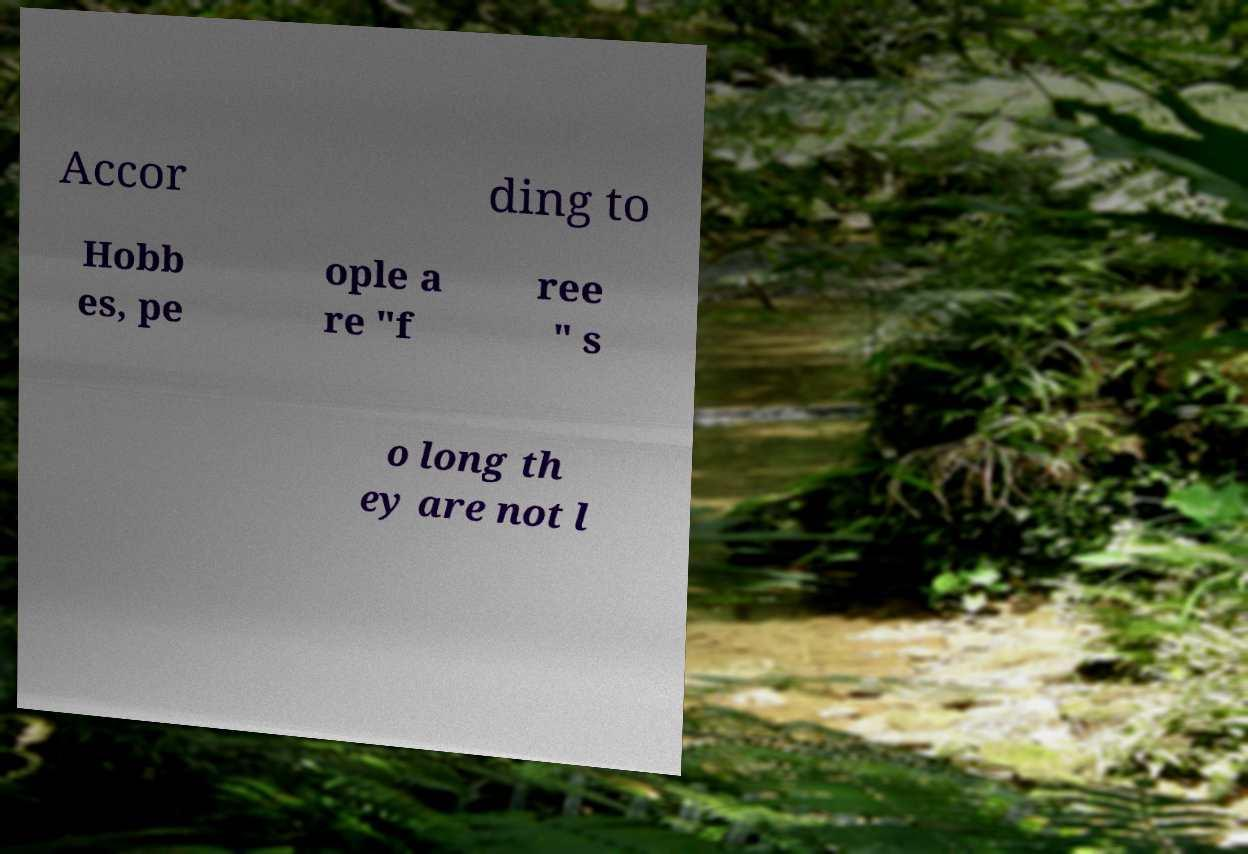Can you accurately transcribe the text from the provided image for me? Accor ding to Hobb es, pe ople a re "f ree " s o long th ey are not l 